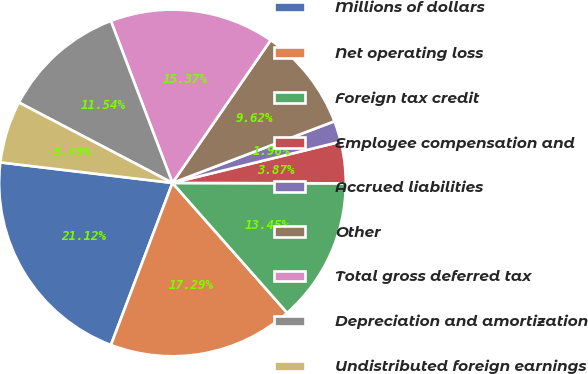<chart> <loc_0><loc_0><loc_500><loc_500><pie_chart><fcel>Millions of dollars<fcel>Net operating loss<fcel>Foreign tax credit<fcel>Employee compensation and<fcel>Accrued liabilities<fcel>Other<fcel>Total gross deferred tax<fcel>Depreciation and amortization<fcel>Undistributed foreign earnings<nl><fcel>21.12%<fcel>17.29%<fcel>13.45%<fcel>3.87%<fcel>1.96%<fcel>9.62%<fcel>15.37%<fcel>11.54%<fcel>5.79%<nl></chart> 